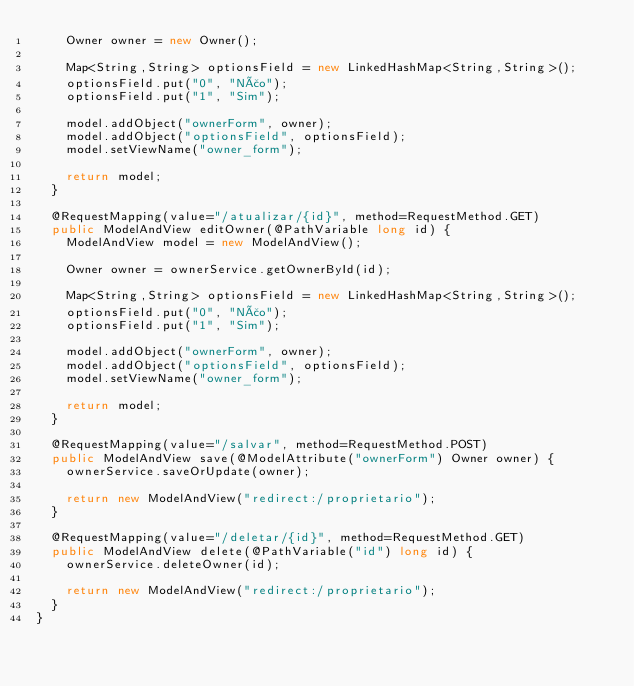Convert code to text. <code><loc_0><loc_0><loc_500><loc_500><_Java_>		Owner owner = new Owner();
		
		Map<String,String> optionsField = new LinkedHashMap<String,String>();
		optionsField.put("0", "Não");
		optionsField.put("1", "Sim");
		
		model.addObject("ownerForm", owner);
		model.addObject("optionsField", optionsField);
		model.setViewName("owner_form");

		return model;
	}

	@RequestMapping(value="/atualizar/{id}", method=RequestMethod.GET)
	public ModelAndView editOwner(@PathVariable long id) {
		ModelAndView model = new ModelAndView();

		Owner owner = ownerService.getOwnerById(id);
		
		Map<String,String> optionsField = new LinkedHashMap<String,String>();
		optionsField.put("0", "Não");
		optionsField.put("1", "Sim");
		
		model.addObject("ownerForm", owner);
		model.addObject("optionsField", optionsField);
		model.setViewName("owner_form");

		return model;
	}

	@RequestMapping(value="/salvar", method=RequestMethod.POST)
	public ModelAndView save(@ModelAttribute("ownerForm") Owner owner) {
		ownerService.saveOrUpdate(owner);

		return new ModelAndView("redirect:/proprietario");
	}

	@RequestMapping(value="/deletar/{id}", method=RequestMethod.GET)
	public ModelAndView delete(@PathVariable("id") long id) {
		ownerService.deleteOwner(id);

		return new ModelAndView("redirect:/proprietario");
	}
}
</code> 